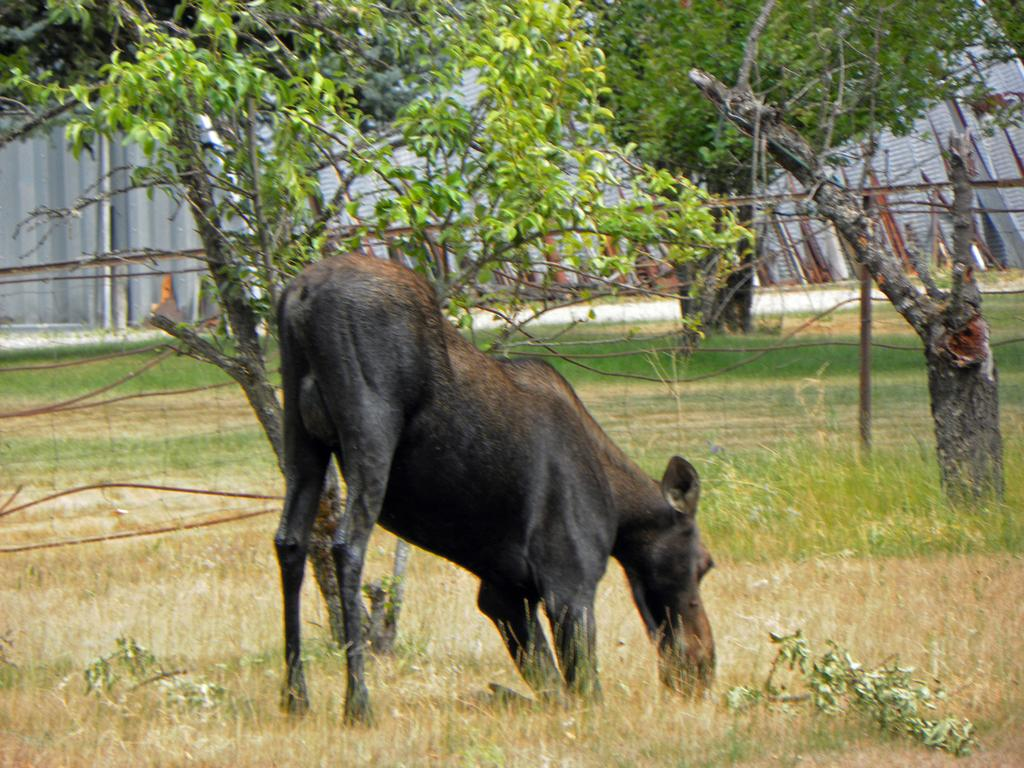What type of animal can be seen in the image? There is an animal in the image, but its specific type cannot be determined from the provided facts. What is the animal doing in the image? The animal is eating grass in the image. What can be seen in the background of the image? There are trees visible in the background of the image. What type of quilt is being used to cover the animal in the image? There is no quilt present in the image, and the animal is not being covered. How many birds are perched on the animal's nose in the image? There are no birds present in the image, and the animal's nose is not mentioned. 